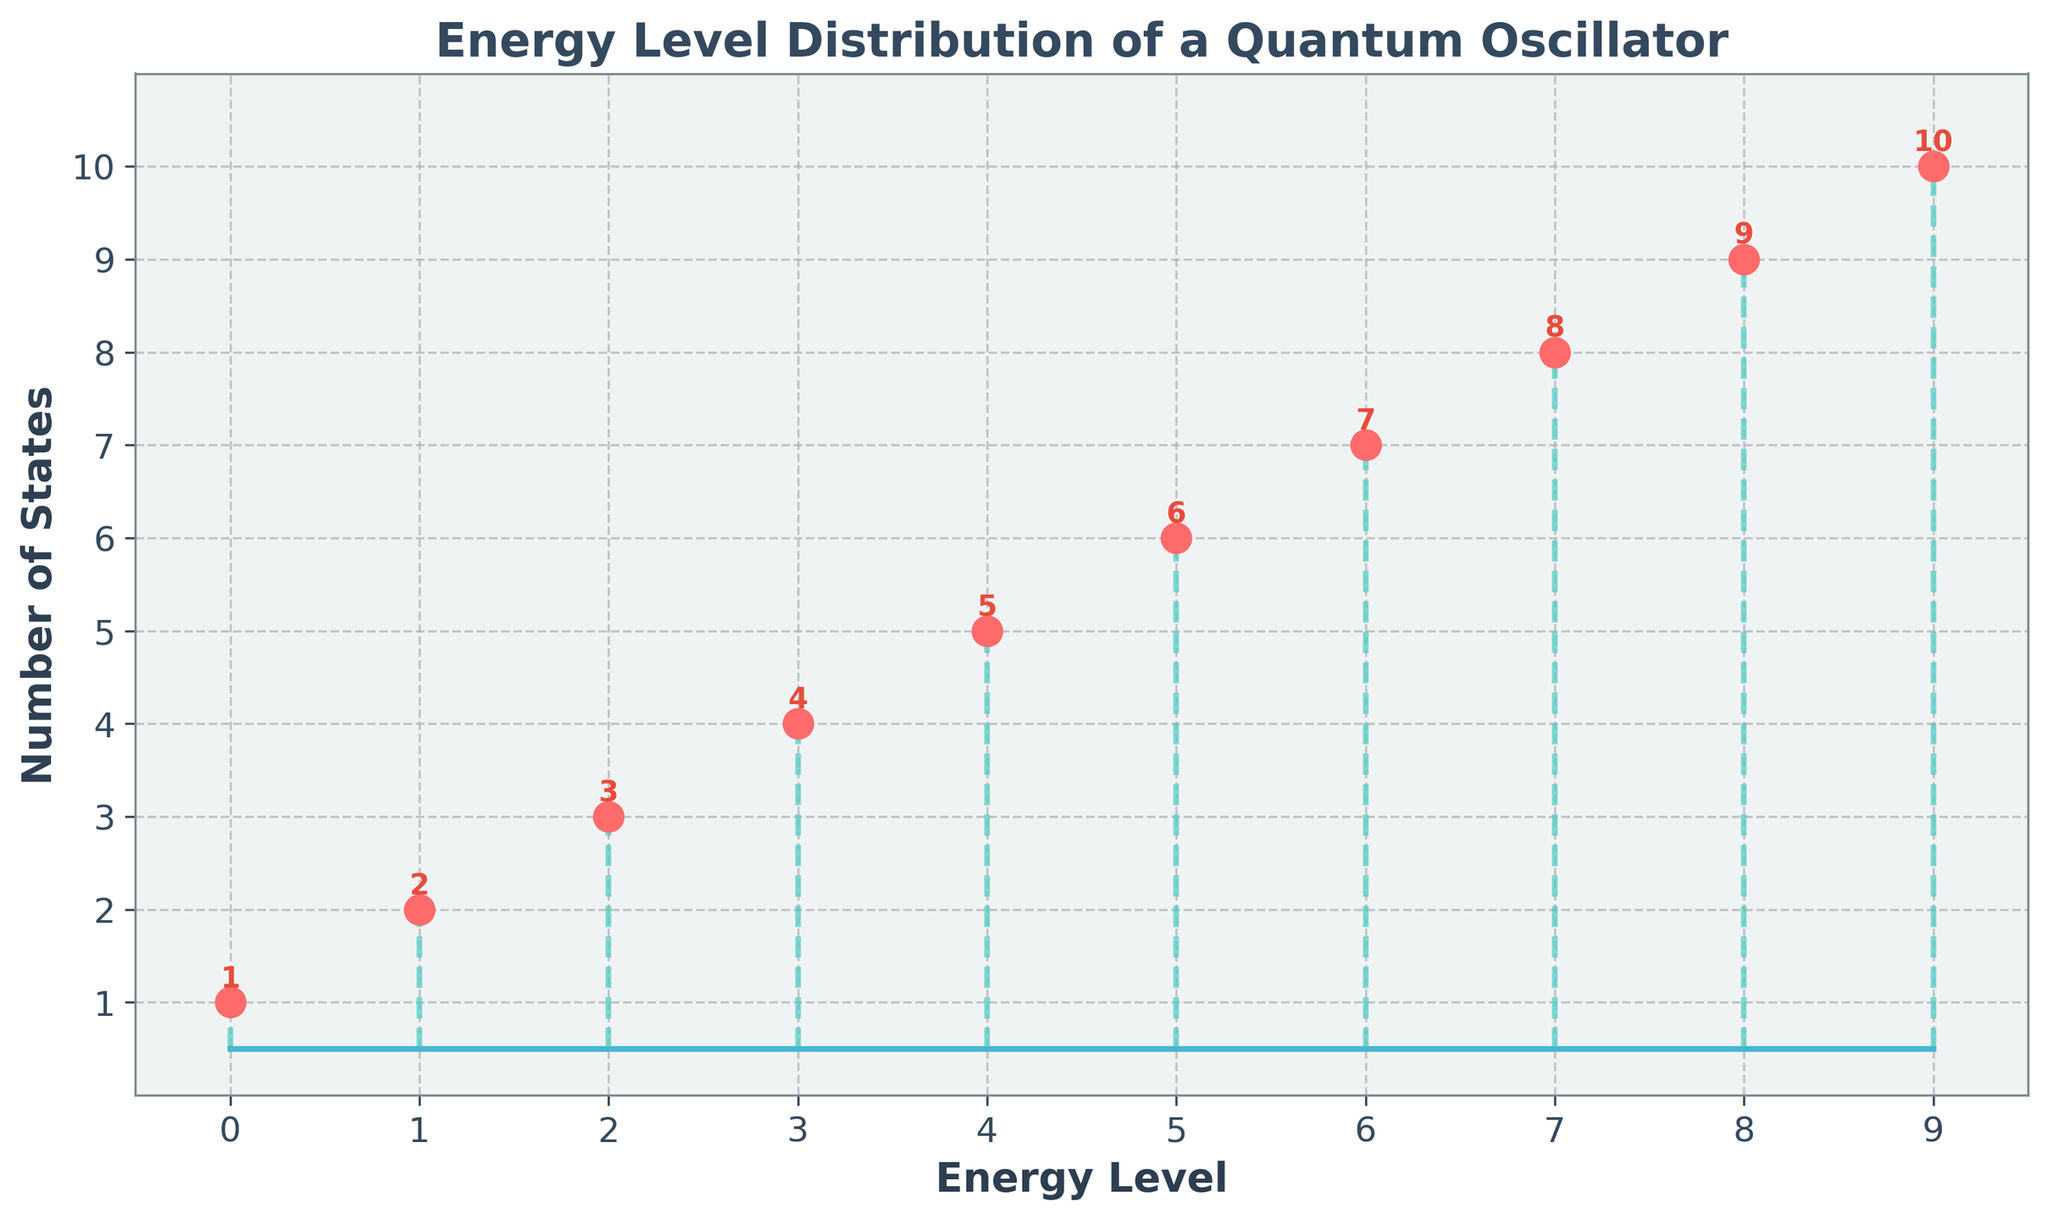What is the title of the plot? The title is usually displayed at the top of the figure. In this case, it indicates the primary subject of the plot.
Answer: Energy Level Distribution of a Quantum Oscillator How many energy levels are shown in the plot? Count the distinct energy levels on the x-axis. Each one corresponds to a separate point on the plot. Here, they range from 0 to 9 inclusive.
Answer: 10 Which data point has the highest number of states? Look for the marker that is at the highest vertical position on the plot. The x-coordinate of this marker represents the energy level, and the y-coordinate indicates the number of states.
Answer: Energy level 9 What is the number of states at energy level 2? Find the marker corresponding to energy level 2 on the x-axis and read its y-coordinate to determine the number of states.
Answer: 3 What color are the marker points in the plot? Identify the color of the circular markers. This color distinguishes the data points from other elements in the plot.
Answer: Red What is the sum of the number of states at energy levels 4 and 5? Look at the markers for energy levels 4 and 5. The y-coordinates of these markers represent the number of states, which need to be summed.
Answer: 5 + 6 = 11 Which energy level has fewer states, level 6 or level 7? Compare the heights of the markers at energy levels 6 and 7. The y-coordinate closest to the x-axis represents the fewer states.
Answer: Energy level 6 What is the average number of states across all energy levels? Calculate the sum of all the number of states and divide by the total number of energy levels (10). (1+2+3+4+5+6+7+8+9+10)/10
Answer: 55 / 10 = 5.5 What does the x-axis represent in the plot? The label on the x-axis specifies what the horizontal axis measures, in this case, it explains the quantities plotted.
Answer: Energy Level Is there a visible pattern in the number of states as the energy level increases? Observe the trend of the markers' vertical positions as you move from left to right along the x-axis. The number of states increases linearly with the energy level.
Answer: Yes, a linear increase 